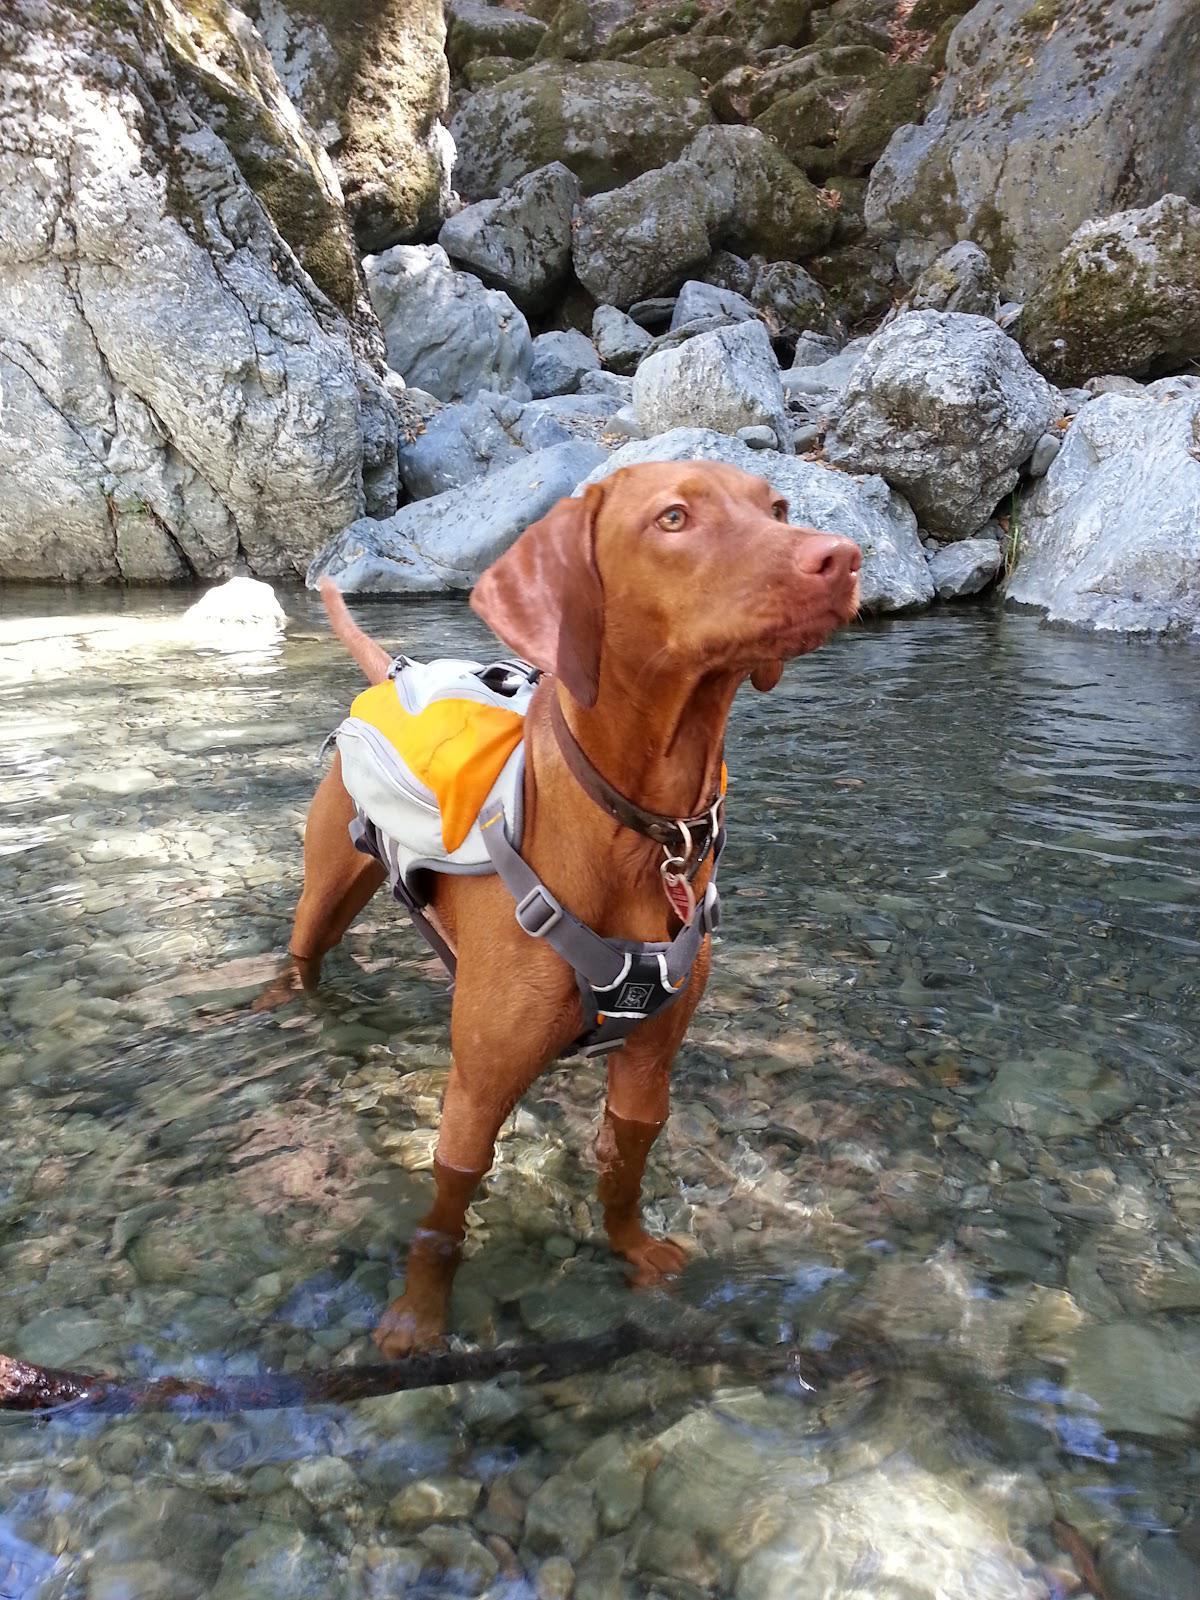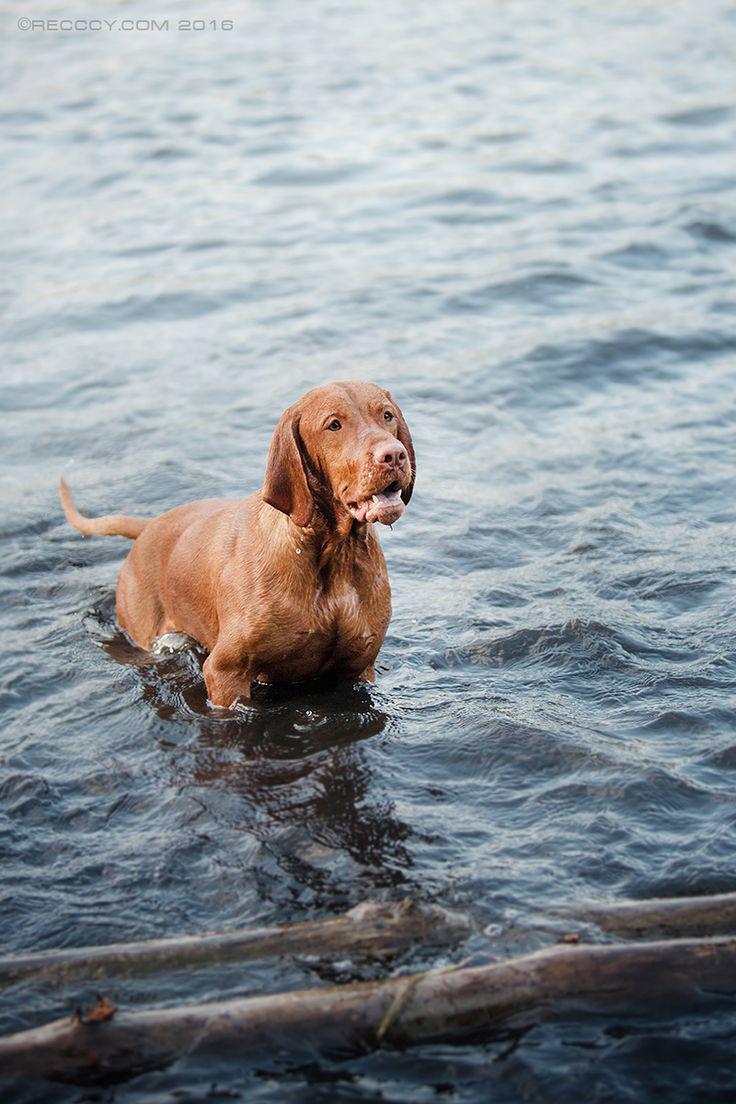The first image is the image on the left, the second image is the image on the right. Considering the images on both sides, is "Exactly one dog is standing in water." valid? Answer yes or no. No. The first image is the image on the left, the second image is the image on the right. For the images displayed, is the sentence "In the left image there is a brown dog sitting on the ground." factually correct? Answer yes or no. No. 